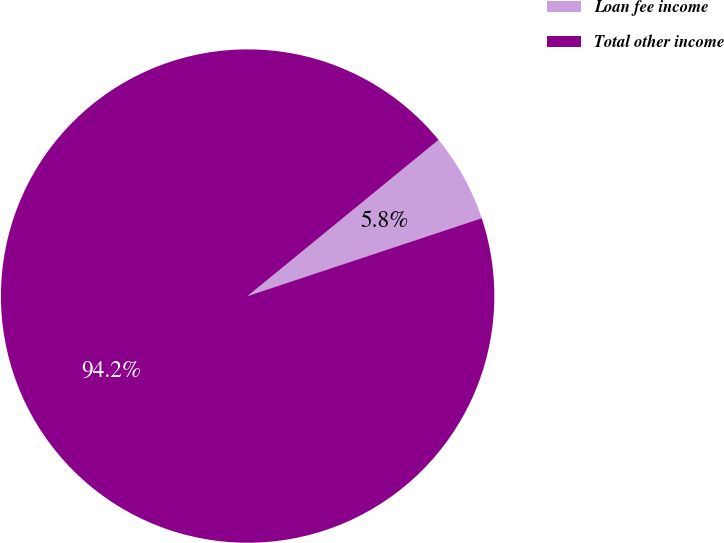<chart> <loc_0><loc_0><loc_500><loc_500><pie_chart><fcel>Loan fee income<fcel>Total other income<nl><fcel>5.8%<fcel>94.2%<nl></chart> 